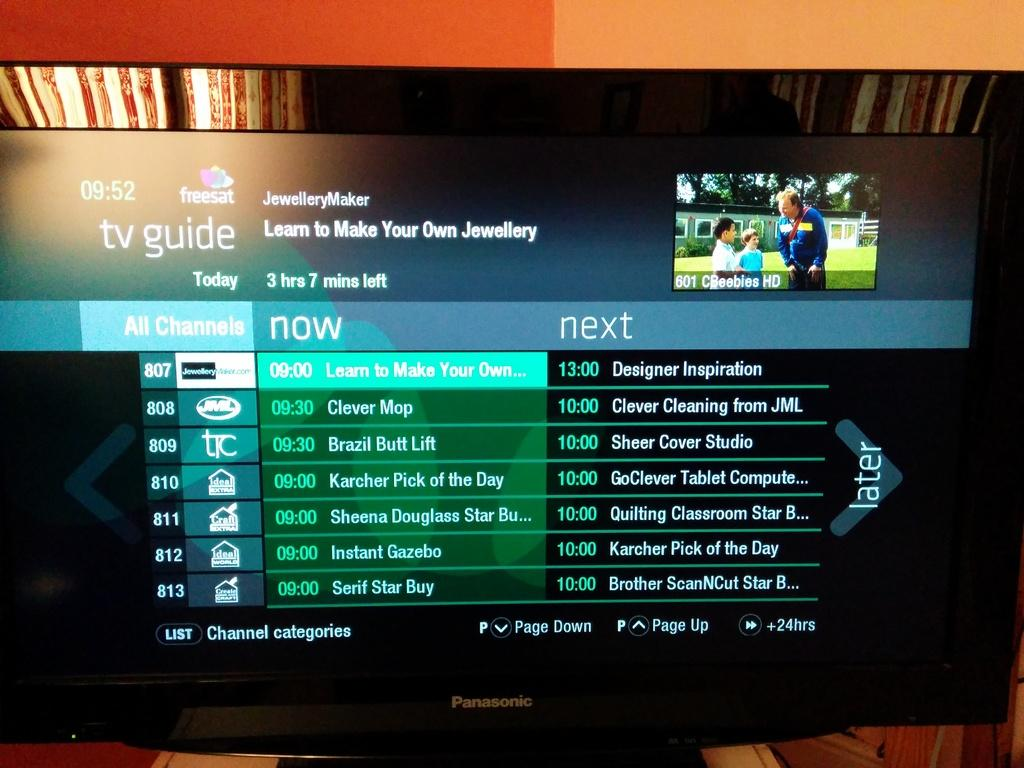What is the main object in the image? There is a screen in the image. What is displayed on the screen? There is a picture of a man with two kids on the screen. Are there any words or phrases on the screen? Yes, there are text on the screen. What can be seen in the background of the image? There is a curtain in the background of the image. What type of knife is being used to take a bite out of the screen in the image? There is no knife or biting action present in the image. 